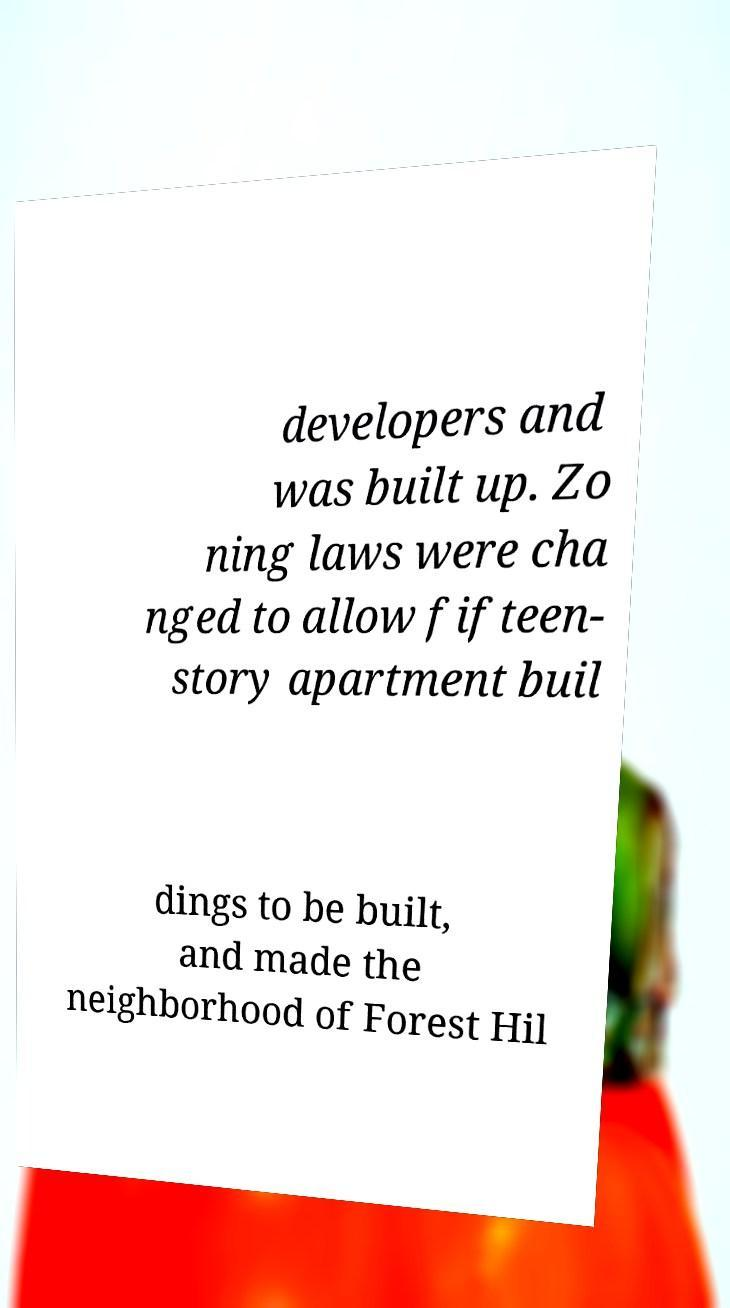For documentation purposes, I need the text within this image transcribed. Could you provide that? developers and was built up. Zo ning laws were cha nged to allow fifteen- story apartment buil dings to be built, and made the neighborhood of Forest Hil 